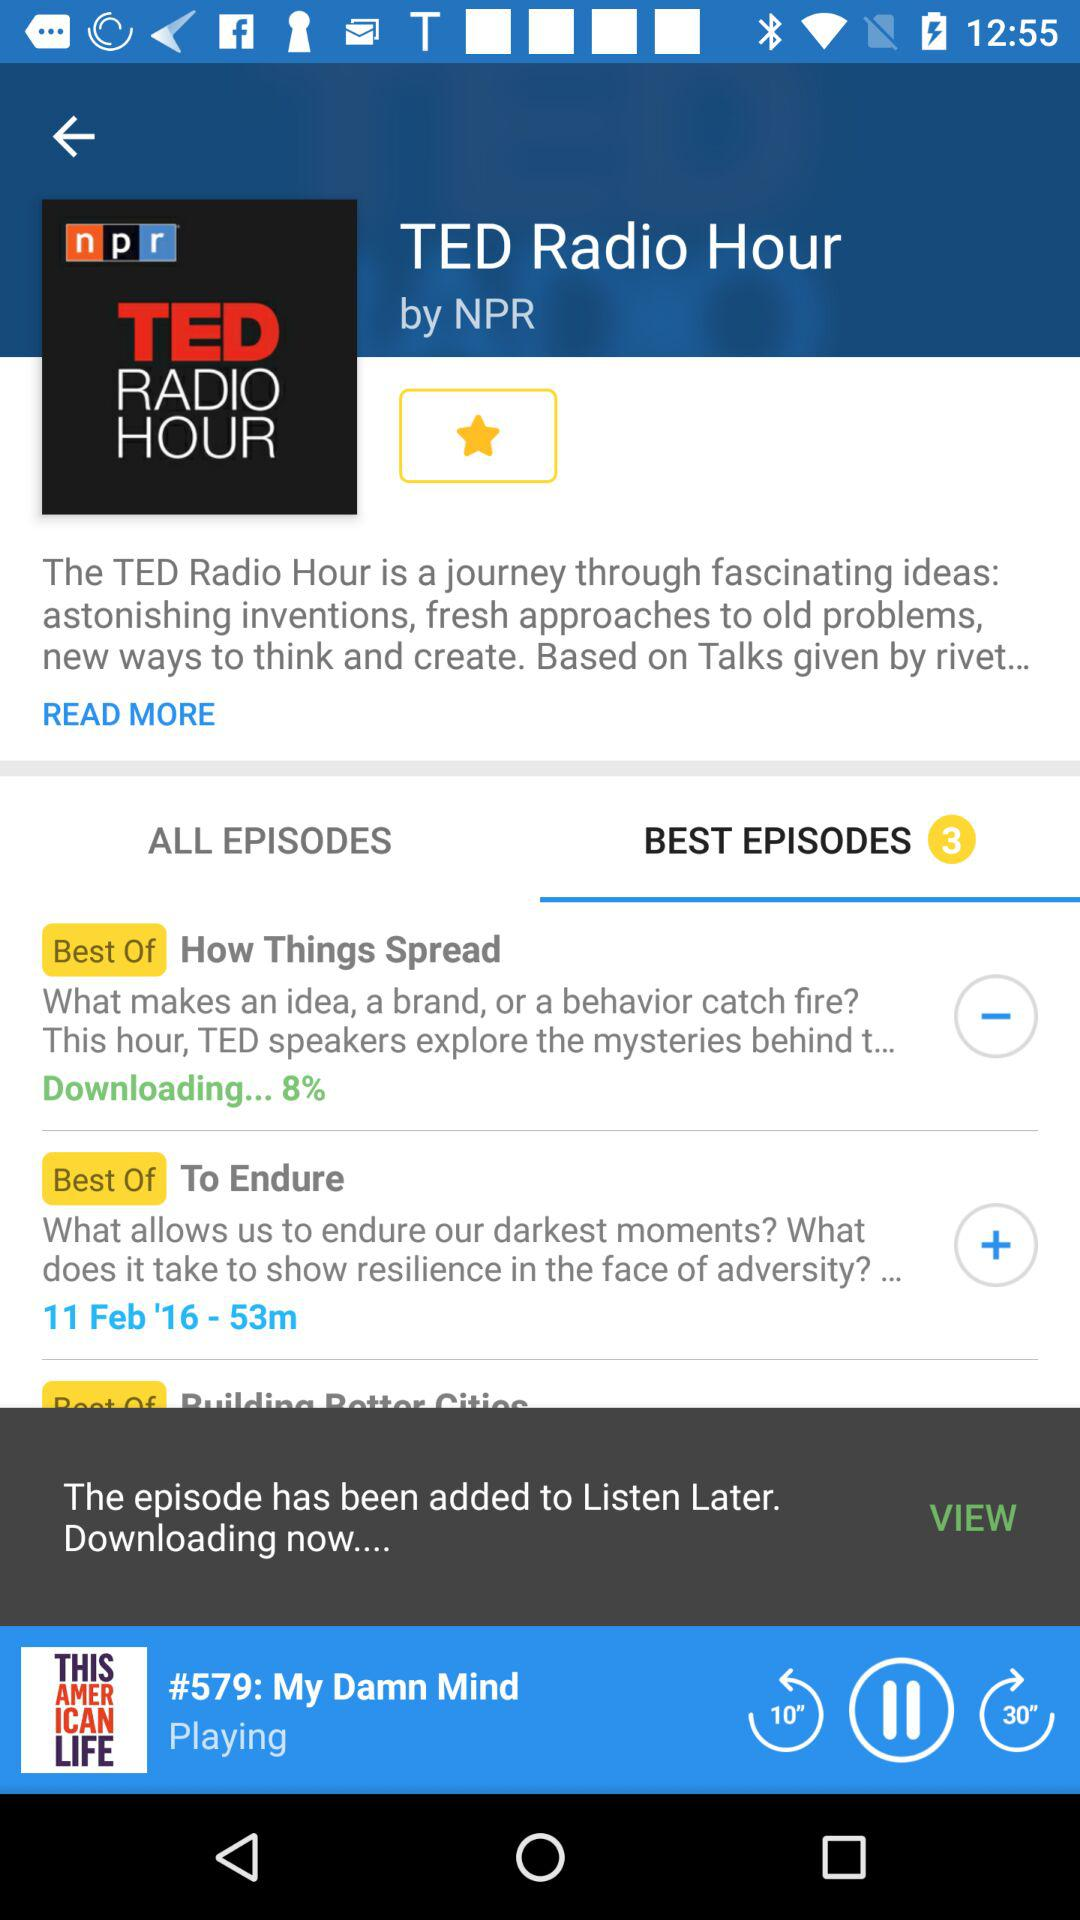What is the time duration of the episode "To Endure"? The time duration of the episode "To Endure" is 53 minutes. 